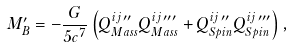<formula> <loc_0><loc_0><loc_500><loc_500>M _ { B } ^ { \prime } = - \frac { G } { 5 c ^ { 7 } } \left ( Q _ { M a s s } ^ { i j \, \prime \prime } Q _ { M a s s } ^ { i j \, \prime \prime \prime } + Q _ { S p i n } ^ { i j \, \prime \prime } Q _ { S p i n } ^ { i j \, \prime \prime \prime } \right ) ,</formula> 